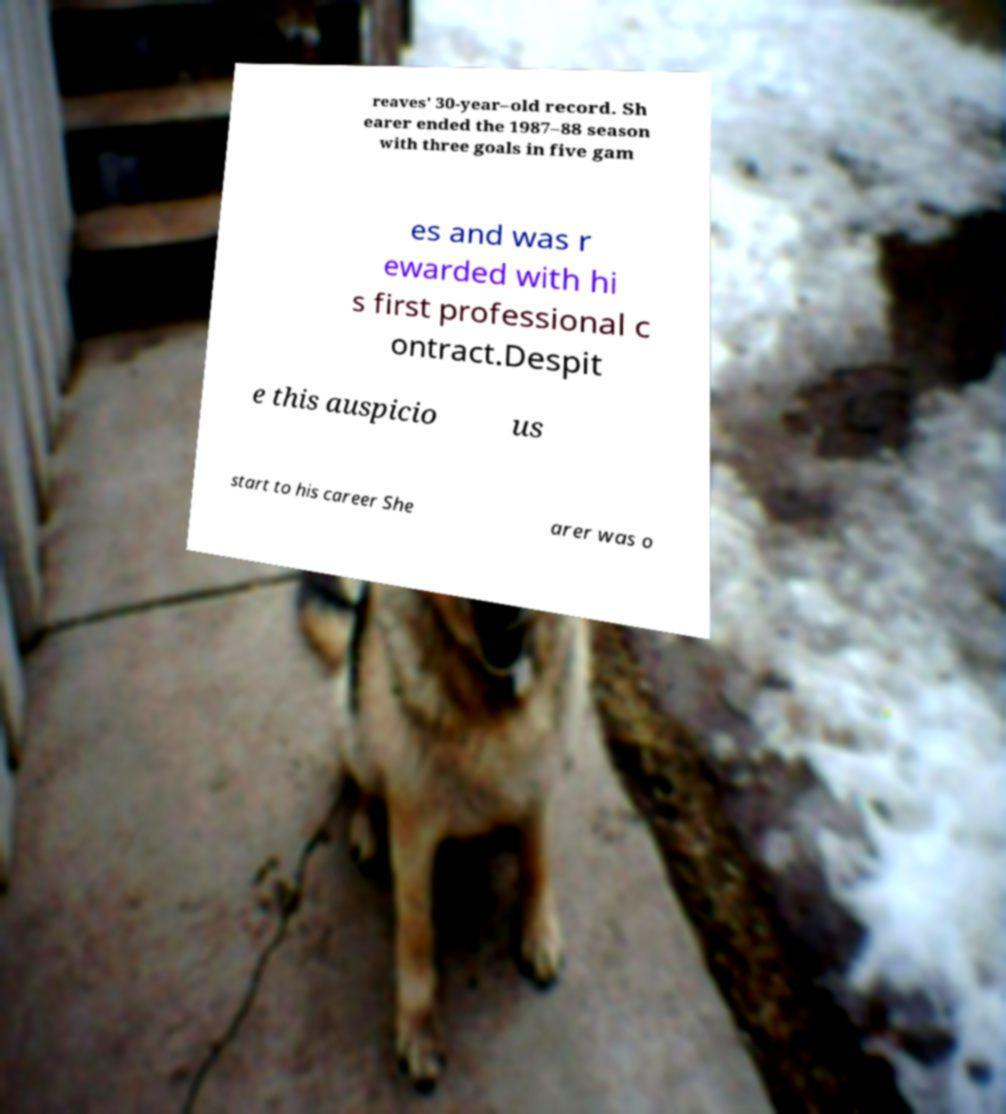Please identify and transcribe the text found in this image. reaves' 30-year–old record. Sh earer ended the 1987–88 season with three goals in five gam es and was r ewarded with hi s first professional c ontract.Despit e this auspicio us start to his career She arer was o 